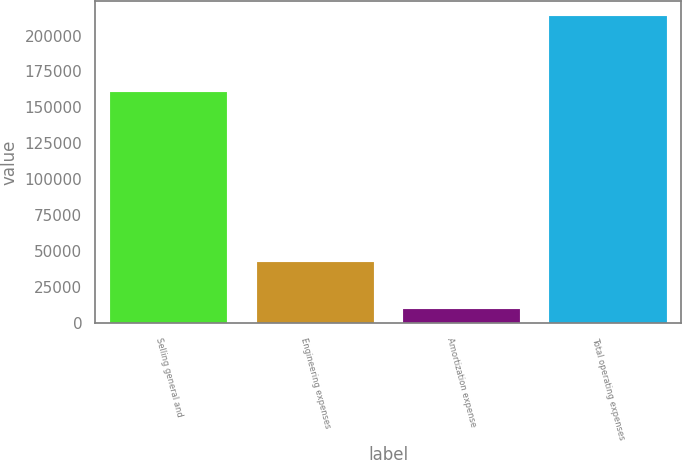Convert chart. <chart><loc_0><loc_0><loc_500><loc_500><bar_chart><fcel>Selling general and<fcel>Engineering expenses<fcel>Amortization expense<fcel>Total operating expenses<nl><fcel>160998<fcel>42447<fcel>9849<fcel>213294<nl></chart> 